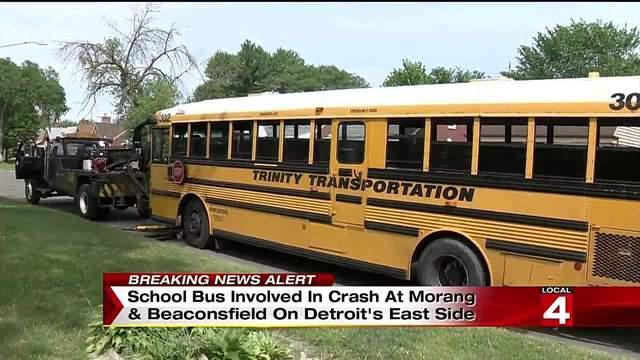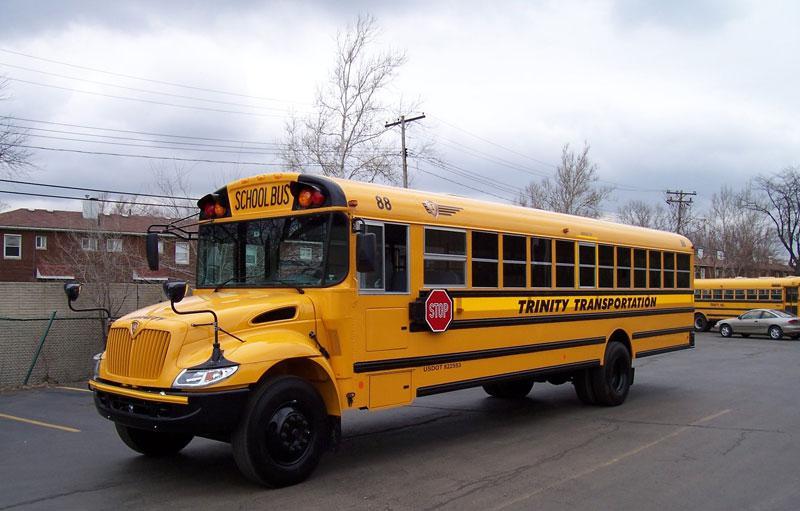The first image is the image on the left, the second image is the image on the right. Assess this claim about the two images: "Each image shows a yellow bus with its non-flat front visible, and at least one bus is shown with the passenger entry door visible.". Correct or not? Answer yes or no. No. 